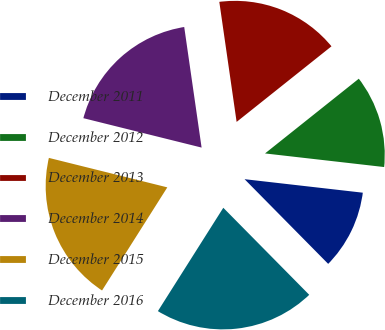Convert chart. <chart><loc_0><loc_0><loc_500><loc_500><pie_chart><fcel>December 2011<fcel>December 2012<fcel>December 2013<fcel>December 2014<fcel>December 2015<fcel>December 2016<nl><fcel>10.79%<fcel>12.52%<fcel>16.57%<fcel>18.84%<fcel>19.9%<fcel>21.38%<nl></chart> 